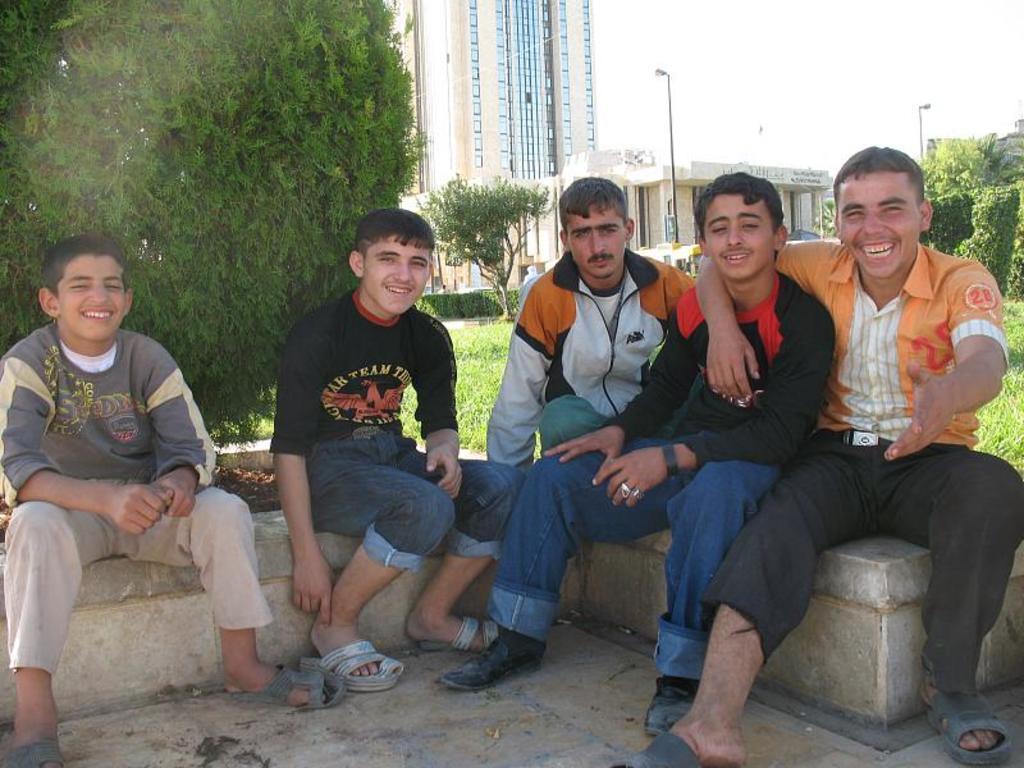Could you give a brief overview of what you see in this image? In this picture we can see a group of people sitting on a surface and smiling, trees, buildings, poles, grass and in the background we can see the sky. 